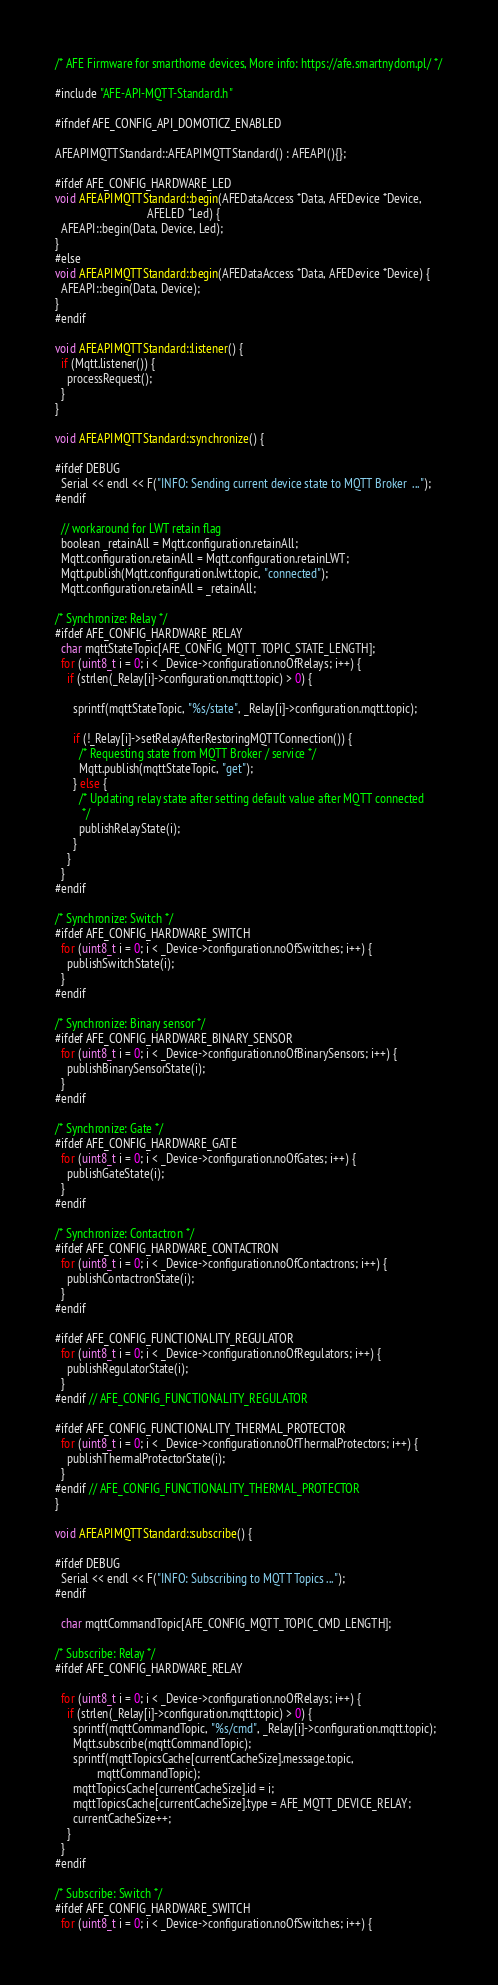Convert code to text. <code><loc_0><loc_0><loc_500><loc_500><_C++_>
/* AFE Firmware for smarthome devices, More info: https://afe.smartnydom.pl/ */

#include "AFE-API-MQTT-Standard.h"

#ifndef AFE_CONFIG_API_DOMOTICZ_ENABLED

AFEAPIMQTTStandard::AFEAPIMQTTStandard() : AFEAPI(){};

#ifdef AFE_CONFIG_HARDWARE_LED
void AFEAPIMQTTStandard::begin(AFEDataAccess *Data, AFEDevice *Device,
                               AFELED *Led) {
  AFEAPI::begin(Data, Device, Led);
}
#else
void AFEAPIMQTTStandard::begin(AFEDataAccess *Data, AFEDevice *Device) {
  AFEAPI::begin(Data, Device);
}
#endif

void AFEAPIMQTTStandard::listener() {
  if (Mqtt.listener()) {
    processRequest();
  }
}

void AFEAPIMQTTStandard::synchronize() {

#ifdef DEBUG
  Serial << endl << F("INFO: Sending current device state to MQTT Broker  ...");
#endif

  // workaround for LWT retain flag
  boolean _retainAll = Mqtt.configuration.retainAll;
  Mqtt.configuration.retainAll = Mqtt.configuration.retainLWT;
  Mqtt.publish(Mqtt.configuration.lwt.topic, "connected");
  Mqtt.configuration.retainAll = _retainAll;

/* Synchronize: Relay */
#ifdef AFE_CONFIG_HARDWARE_RELAY
  char mqttStateTopic[AFE_CONFIG_MQTT_TOPIC_STATE_LENGTH];
  for (uint8_t i = 0; i < _Device->configuration.noOfRelays; i++) {
    if (strlen(_Relay[i]->configuration.mqtt.topic) > 0) {

      sprintf(mqttStateTopic, "%s/state", _Relay[i]->configuration.mqtt.topic);

      if (!_Relay[i]->setRelayAfterRestoringMQTTConnection()) {
        /* Requesting state from MQTT Broker / service */
        Mqtt.publish(mqttStateTopic, "get");
      } else {
        /* Updating relay state after setting default value after MQTT connected
         */
        publishRelayState(i);
      }
    }
  }
#endif

/* Synchronize: Switch */
#ifdef AFE_CONFIG_HARDWARE_SWITCH
  for (uint8_t i = 0; i < _Device->configuration.noOfSwitches; i++) {
    publishSwitchState(i);
  }
#endif

/* Synchronize: Binary sensor */
#ifdef AFE_CONFIG_HARDWARE_BINARY_SENSOR
  for (uint8_t i = 0; i < _Device->configuration.noOfBinarySensors; i++) {
    publishBinarySensorState(i);
  }
#endif

/* Synchronize: Gate */
#ifdef AFE_CONFIG_HARDWARE_GATE
  for (uint8_t i = 0; i < _Device->configuration.noOfGates; i++) {
    publishGateState(i);
  }
#endif

/* Synchronize: Contactron */
#ifdef AFE_CONFIG_HARDWARE_CONTACTRON
  for (uint8_t i = 0; i < _Device->configuration.noOfContactrons; i++) {
    publishContactronState(i);
  }
#endif

#ifdef AFE_CONFIG_FUNCTIONALITY_REGULATOR
  for (uint8_t i = 0; i < _Device->configuration.noOfRegulators; i++) {
    publishRegulatorState(i);
  }
#endif // AFE_CONFIG_FUNCTIONALITY_REGULATOR

#ifdef AFE_CONFIG_FUNCTIONALITY_THERMAL_PROTECTOR
  for (uint8_t i = 0; i < _Device->configuration.noOfThermalProtectors; i++) {
    publishThermalProtectorState(i);
  }
#endif // AFE_CONFIG_FUNCTIONALITY_THERMAL_PROTECTOR
}

void AFEAPIMQTTStandard::subscribe() {

#ifdef DEBUG
  Serial << endl << F("INFO: Subscribing to MQTT Topics ...");
#endif

  char mqttCommandTopic[AFE_CONFIG_MQTT_TOPIC_CMD_LENGTH];

/* Subscribe: Relay */
#ifdef AFE_CONFIG_HARDWARE_RELAY

  for (uint8_t i = 0; i < _Device->configuration.noOfRelays; i++) {
    if (strlen(_Relay[i]->configuration.mqtt.topic) > 0) {
      sprintf(mqttCommandTopic, "%s/cmd", _Relay[i]->configuration.mqtt.topic);
      Mqtt.subscribe(mqttCommandTopic);
      sprintf(mqttTopicsCache[currentCacheSize].message.topic,
              mqttCommandTopic);
      mqttTopicsCache[currentCacheSize].id = i;
      mqttTopicsCache[currentCacheSize].type = AFE_MQTT_DEVICE_RELAY;
      currentCacheSize++;
    }
  }
#endif

/* Subscribe: Switch */
#ifdef AFE_CONFIG_HARDWARE_SWITCH
  for (uint8_t i = 0; i < _Device->configuration.noOfSwitches; i++) {</code> 